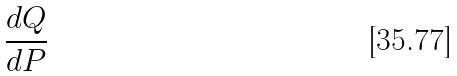<formula> <loc_0><loc_0><loc_500><loc_500>\frac { d Q } { d P }</formula> 